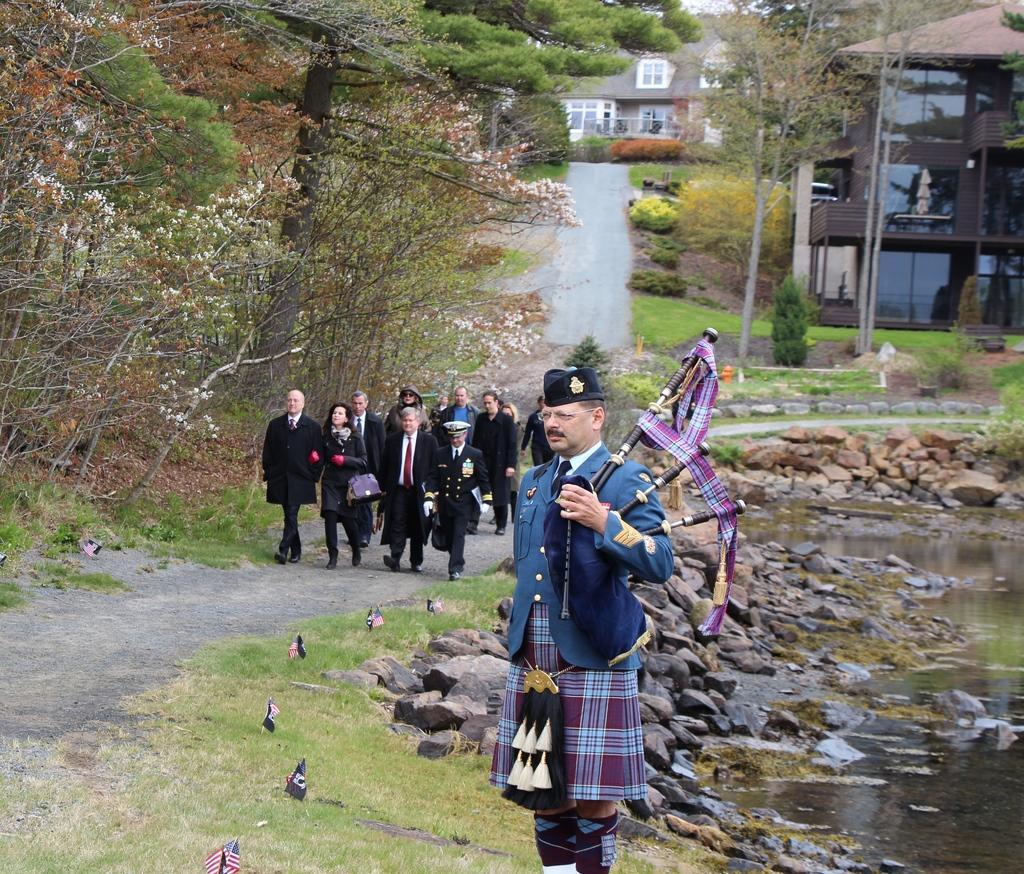Please provide a concise description of this image. In this image, we can see some trees and plants. There is a person at the bottom of the image standing and holding a musical instrument with his hand. There are group of people walking on the road. There is a lake in the bottom right of the image. There are roof houses in the top right of the image. 